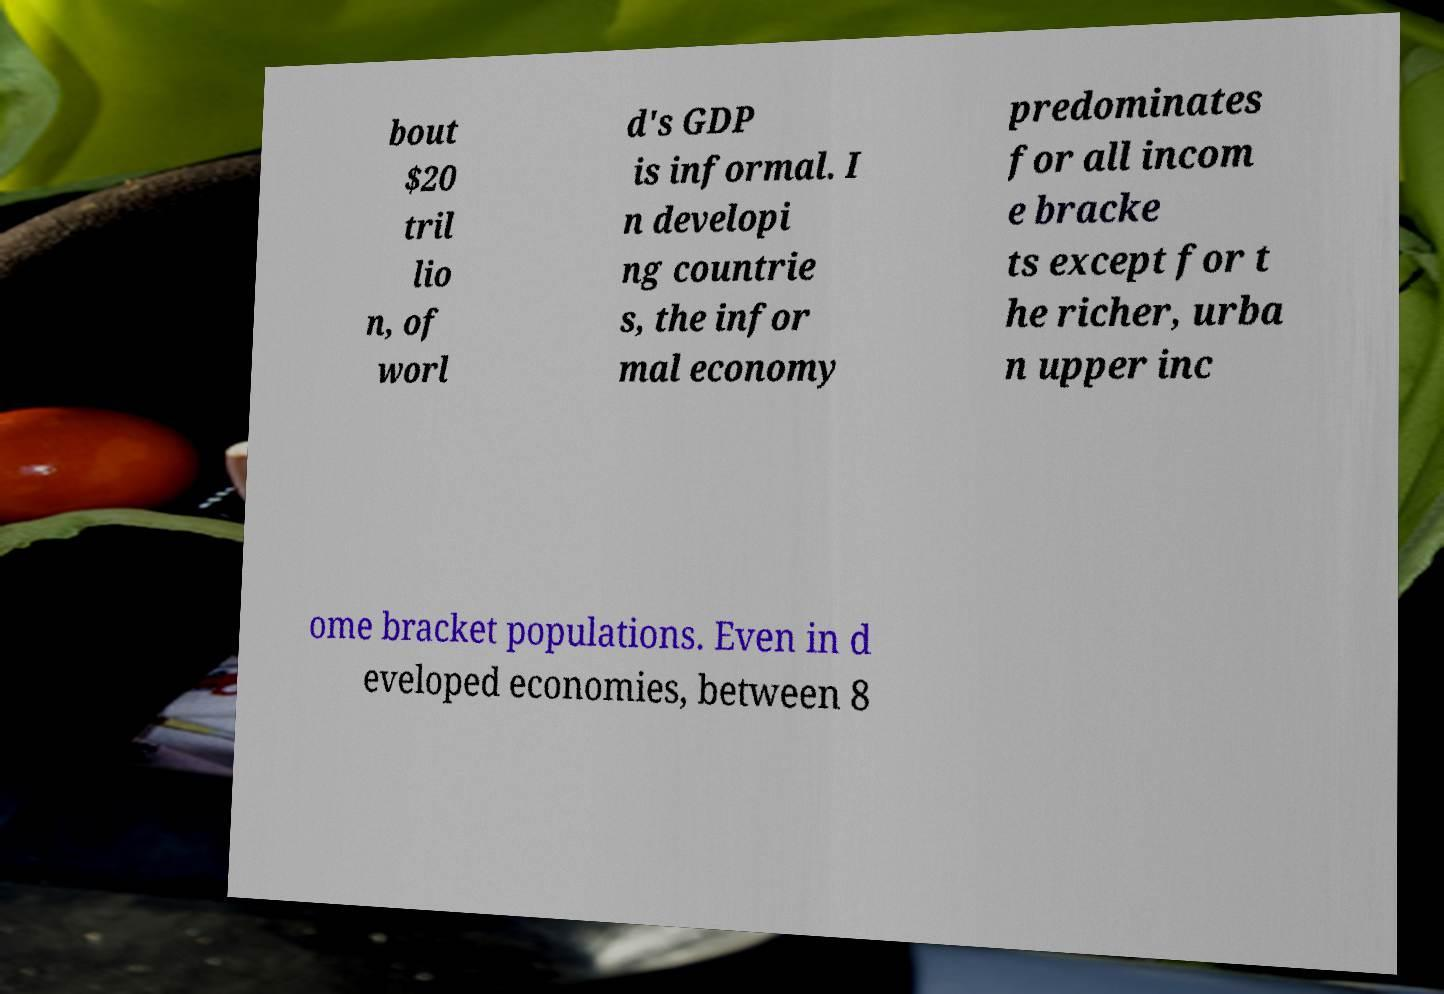Can you accurately transcribe the text from the provided image for me? bout $20 tril lio n, of worl d's GDP is informal. I n developi ng countrie s, the infor mal economy predominates for all incom e bracke ts except for t he richer, urba n upper inc ome bracket populations. Even in d eveloped economies, between 8 